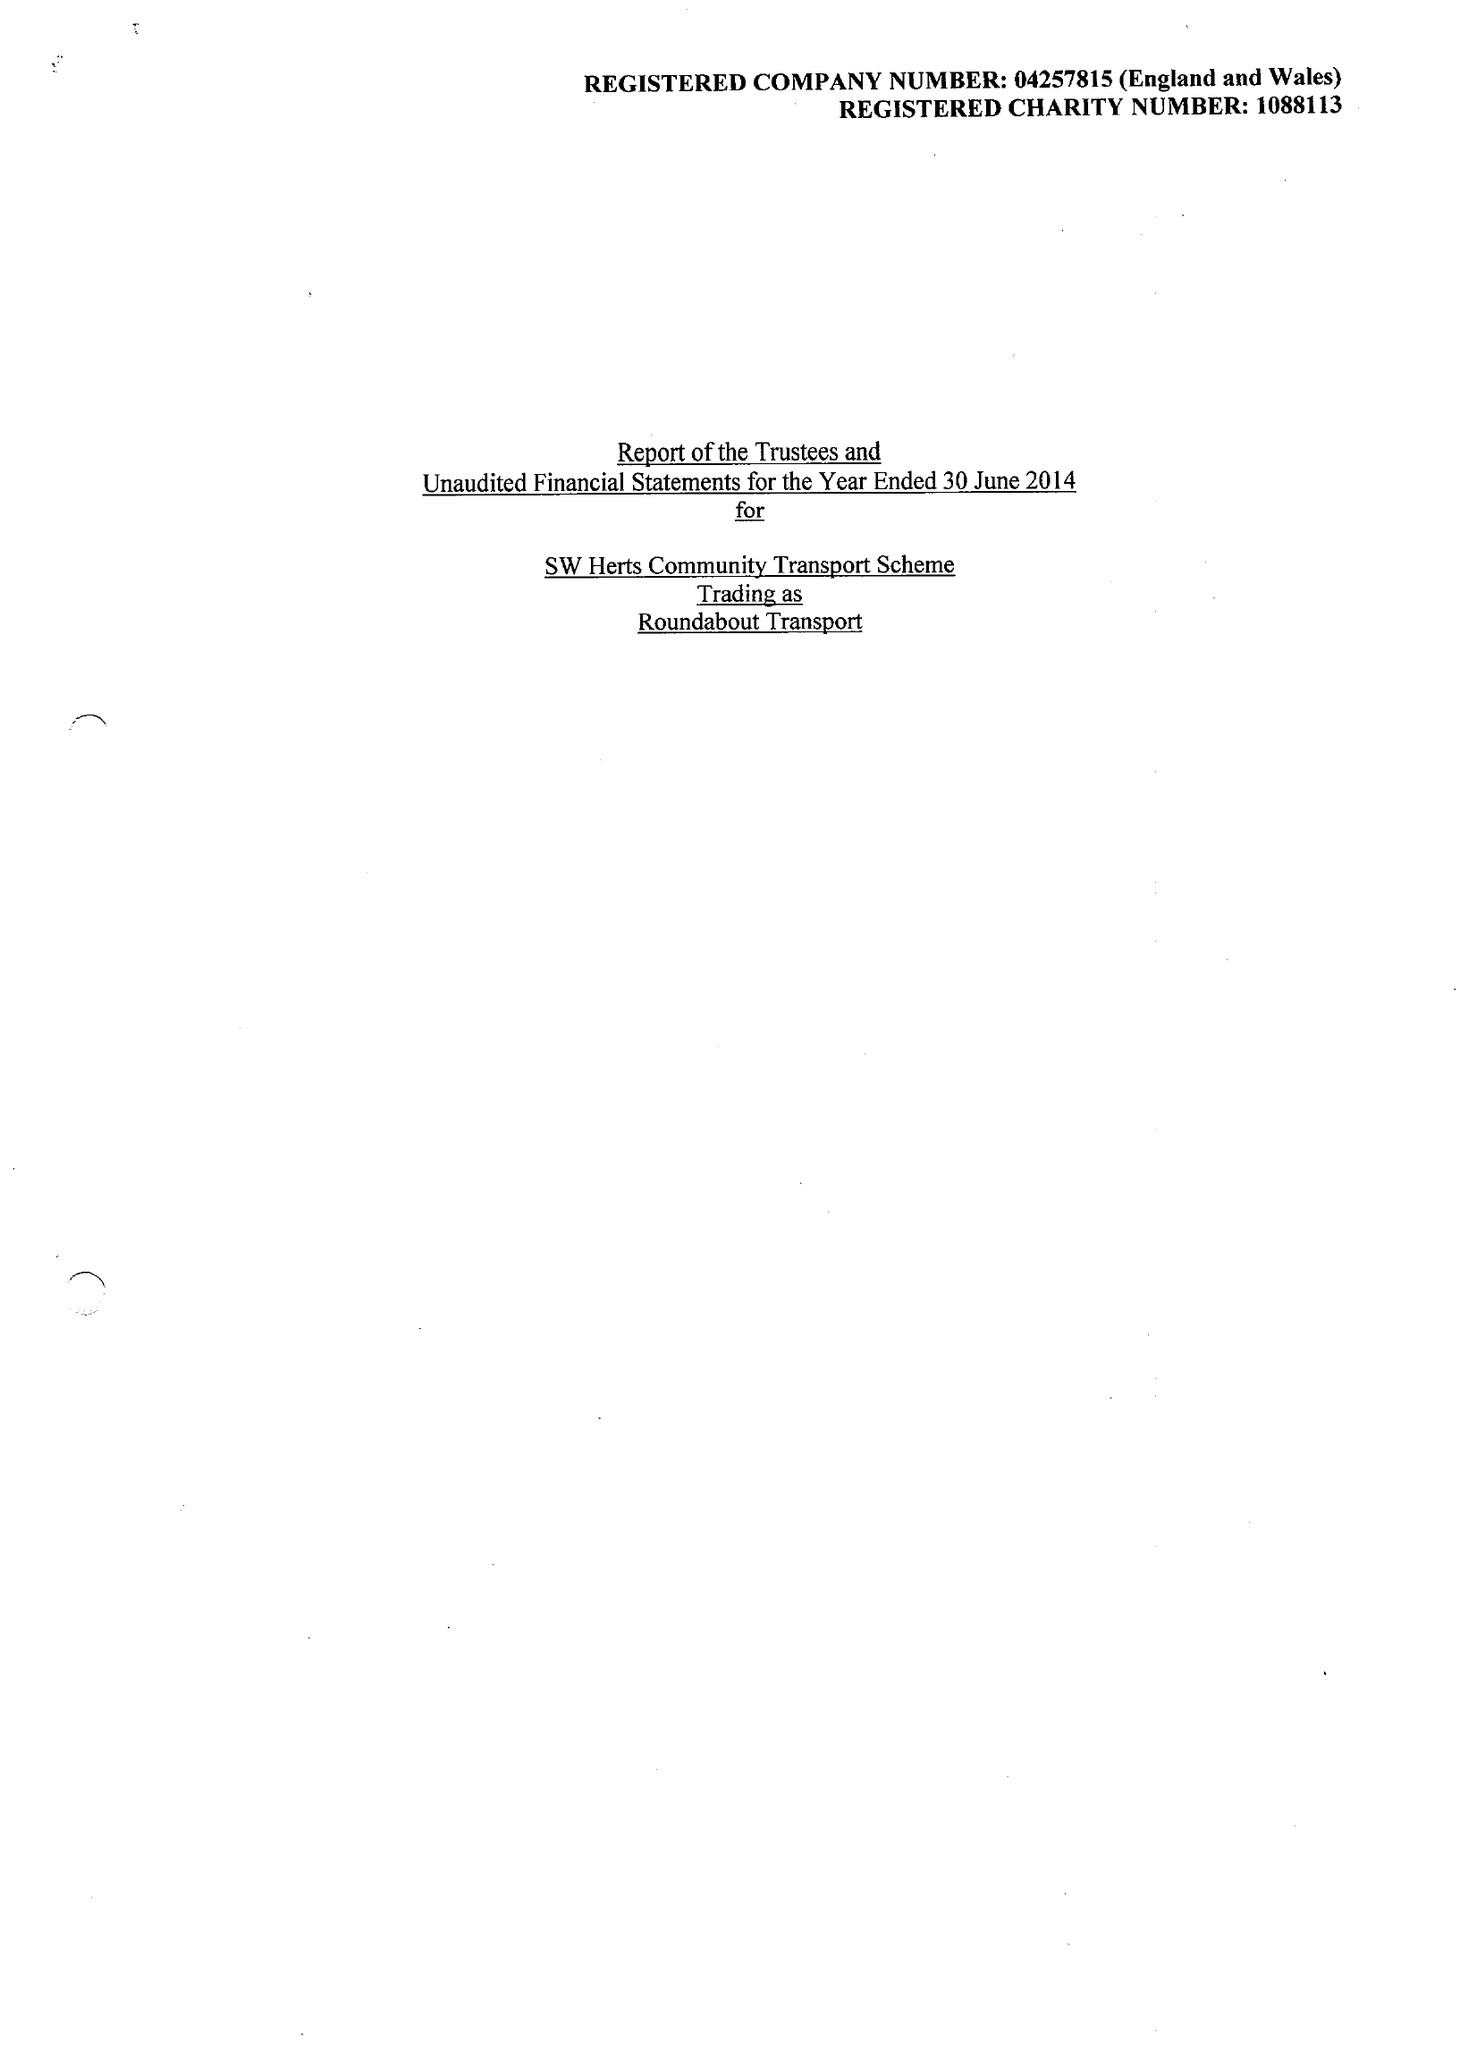What is the value for the charity_number?
Answer the question using a single word or phrase. 1088113 